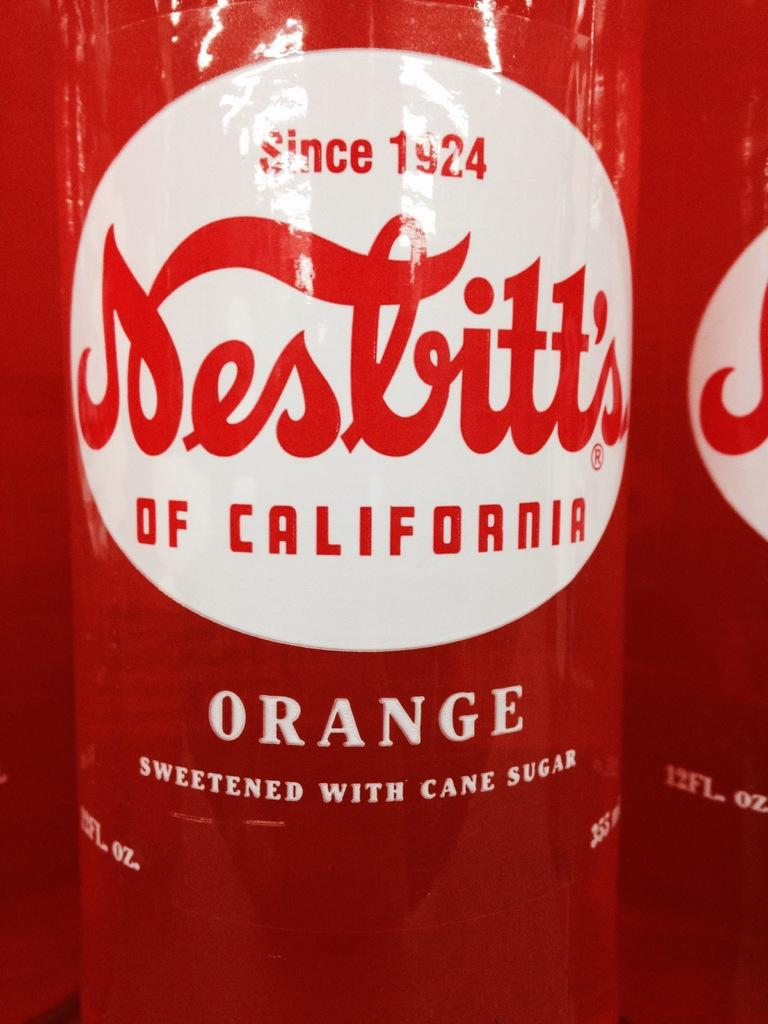<image>
Describe the image concisely. A clear bottle of orange flavored soda whose brand was espablished in 1924. 